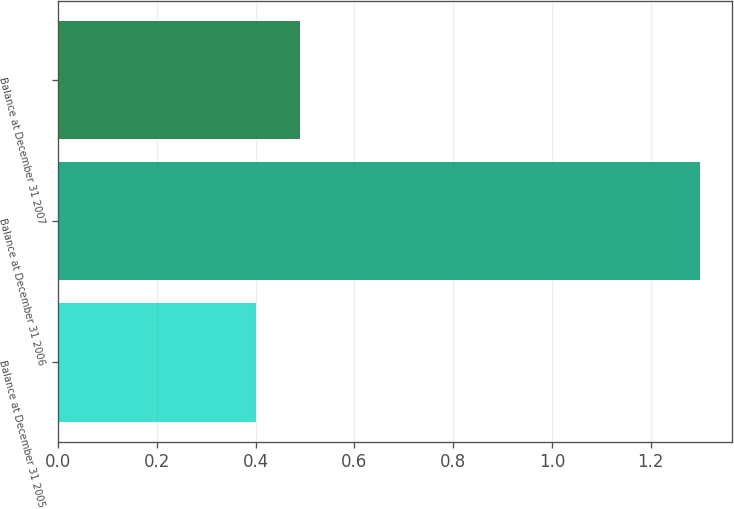Convert chart. <chart><loc_0><loc_0><loc_500><loc_500><bar_chart><fcel>Balance at December 31 2005<fcel>Balance at December 31 2006<fcel>Balance at December 31 2007<nl><fcel>0.4<fcel>1.3<fcel>0.49<nl></chart> 